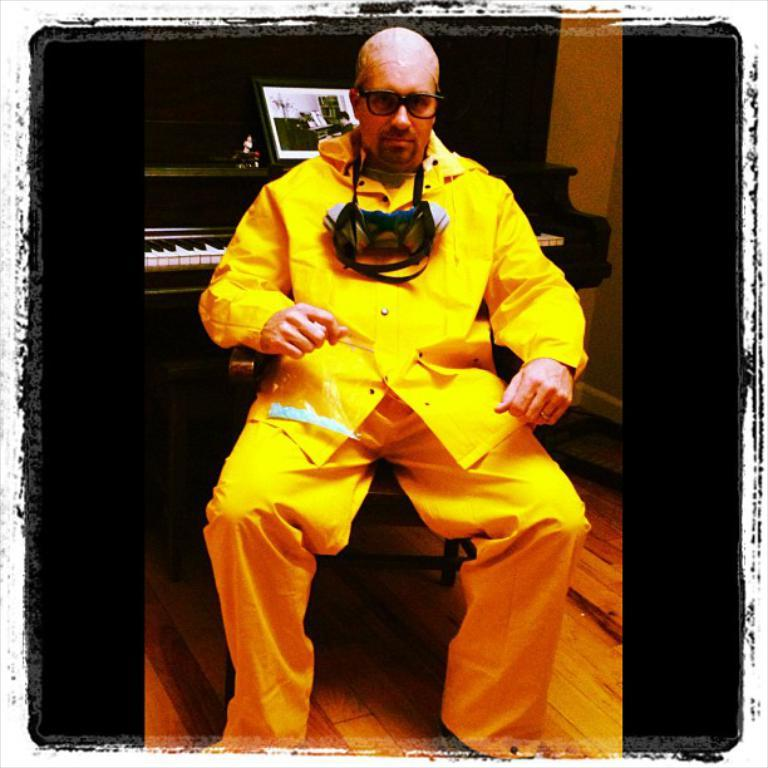What is the person in the image sitting on? The person is sitting on a wooden chair in the image. What color is the shirt the person is wearing? The person is wearing a yellow shirt. What type of clothing is the person wearing on their lower body? The person is wearing pants. What musical instrument is visible behind the person? There is a piano behind the person in the image. What object related to reading or learning is present near the piano? There is a book on or near the piano. How many legs can be seen on the car in the image? There is no car present in the image; it features a person sitting on a wooden chair with a piano and a book nearby. 